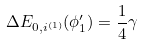<formula> <loc_0><loc_0><loc_500><loc_500>\Delta E _ { 0 , i ^ { ( 1 ) } } ( \phi _ { 1 } ^ { \prime } ) = \frac { 1 } { 4 } \gamma</formula> 